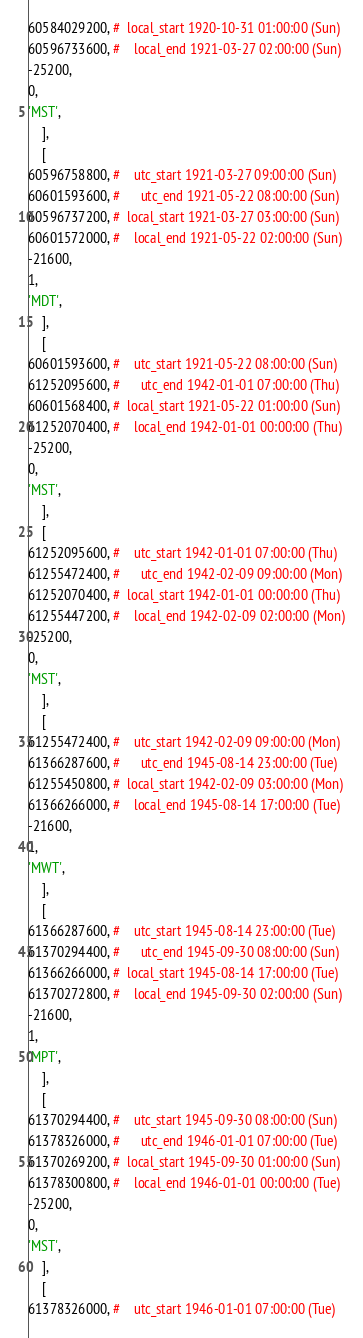Convert code to text. <code><loc_0><loc_0><loc_500><loc_500><_Perl_>60584029200, #  local_start 1920-10-31 01:00:00 (Sun)
60596733600, #    local_end 1921-03-27 02:00:00 (Sun)
-25200,
0,
'MST',
    ],
    [
60596758800, #    utc_start 1921-03-27 09:00:00 (Sun)
60601593600, #      utc_end 1921-05-22 08:00:00 (Sun)
60596737200, #  local_start 1921-03-27 03:00:00 (Sun)
60601572000, #    local_end 1921-05-22 02:00:00 (Sun)
-21600,
1,
'MDT',
    ],
    [
60601593600, #    utc_start 1921-05-22 08:00:00 (Sun)
61252095600, #      utc_end 1942-01-01 07:00:00 (Thu)
60601568400, #  local_start 1921-05-22 01:00:00 (Sun)
61252070400, #    local_end 1942-01-01 00:00:00 (Thu)
-25200,
0,
'MST',
    ],
    [
61252095600, #    utc_start 1942-01-01 07:00:00 (Thu)
61255472400, #      utc_end 1942-02-09 09:00:00 (Mon)
61252070400, #  local_start 1942-01-01 00:00:00 (Thu)
61255447200, #    local_end 1942-02-09 02:00:00 (Mon)
-25200,
0,
'MST',
    ],
    [
61255472400, #    utc_start 1942-02-09 09:00:00 (Mon)
61366287600, #      utc_end 1945-08-14 23:00:00 (Tue)
61255450800, #  local_start 1942-02-09 03:00:00 (Mon)
61366266000, #    local_end 1945-08-14 17:00:00 (Tue)
-21600,
1,
'MWT',
    ],
    [
61366287600, #    utc_start 1945-08-14 23:00:00 (Tue)
61370294400, #      utc_end 1945-09-30 08:00:00 (Sun)
61366266000, #  local_start 1945-08-14 17:00:00 (Tue)
61370272800, #    local_end 1945-09-30 02:00:00 (Sun)
-21600,
1,
'MPT',
    ],
    [
61370294400, #    utc_start 1945-09-30 08:00:00 (Sun)
61378326000, #      utc_end 1946-01-01 07:00:00 (Tue)
61370269200, #  local_start 1945-09-30 01:00:00 (Sun)
61378300800, #    local_end 1946-01-01 00:00:00 (Tue)
-25200,
0,
'MST',
    ],
    [
61378326000, #    utc_start 1946-01-01 07:00:00 (Tue)</code> 